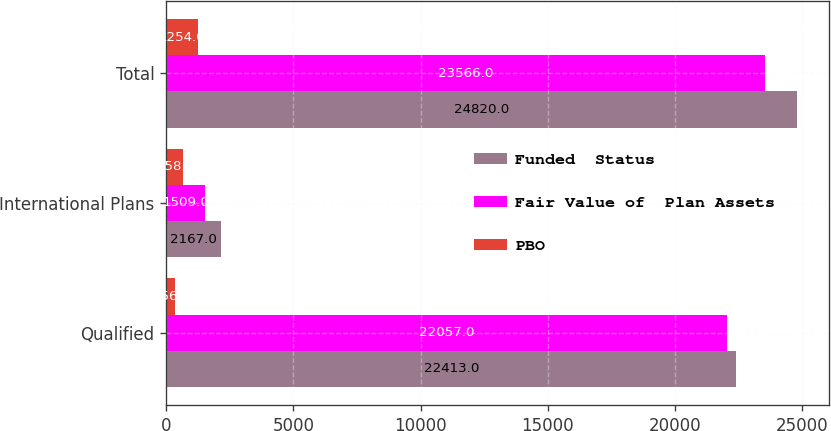<chart> <loc_0><loc_0><loc_500><loc_500><stacked_bar_chart><ecel><fcel>Qualified<fcel>International Plans<fcel>Total<nl><fcel>Funded  Status<fcel>22413<fcel>2167<fcel>24820<nl><fcel>Fair Value of  Plan Assets<fcel>22057<fcel>1509<fcel>23566<nl><fcel>PBO<fcel>356<fcel>658<fcel>1254<nl></chart> 